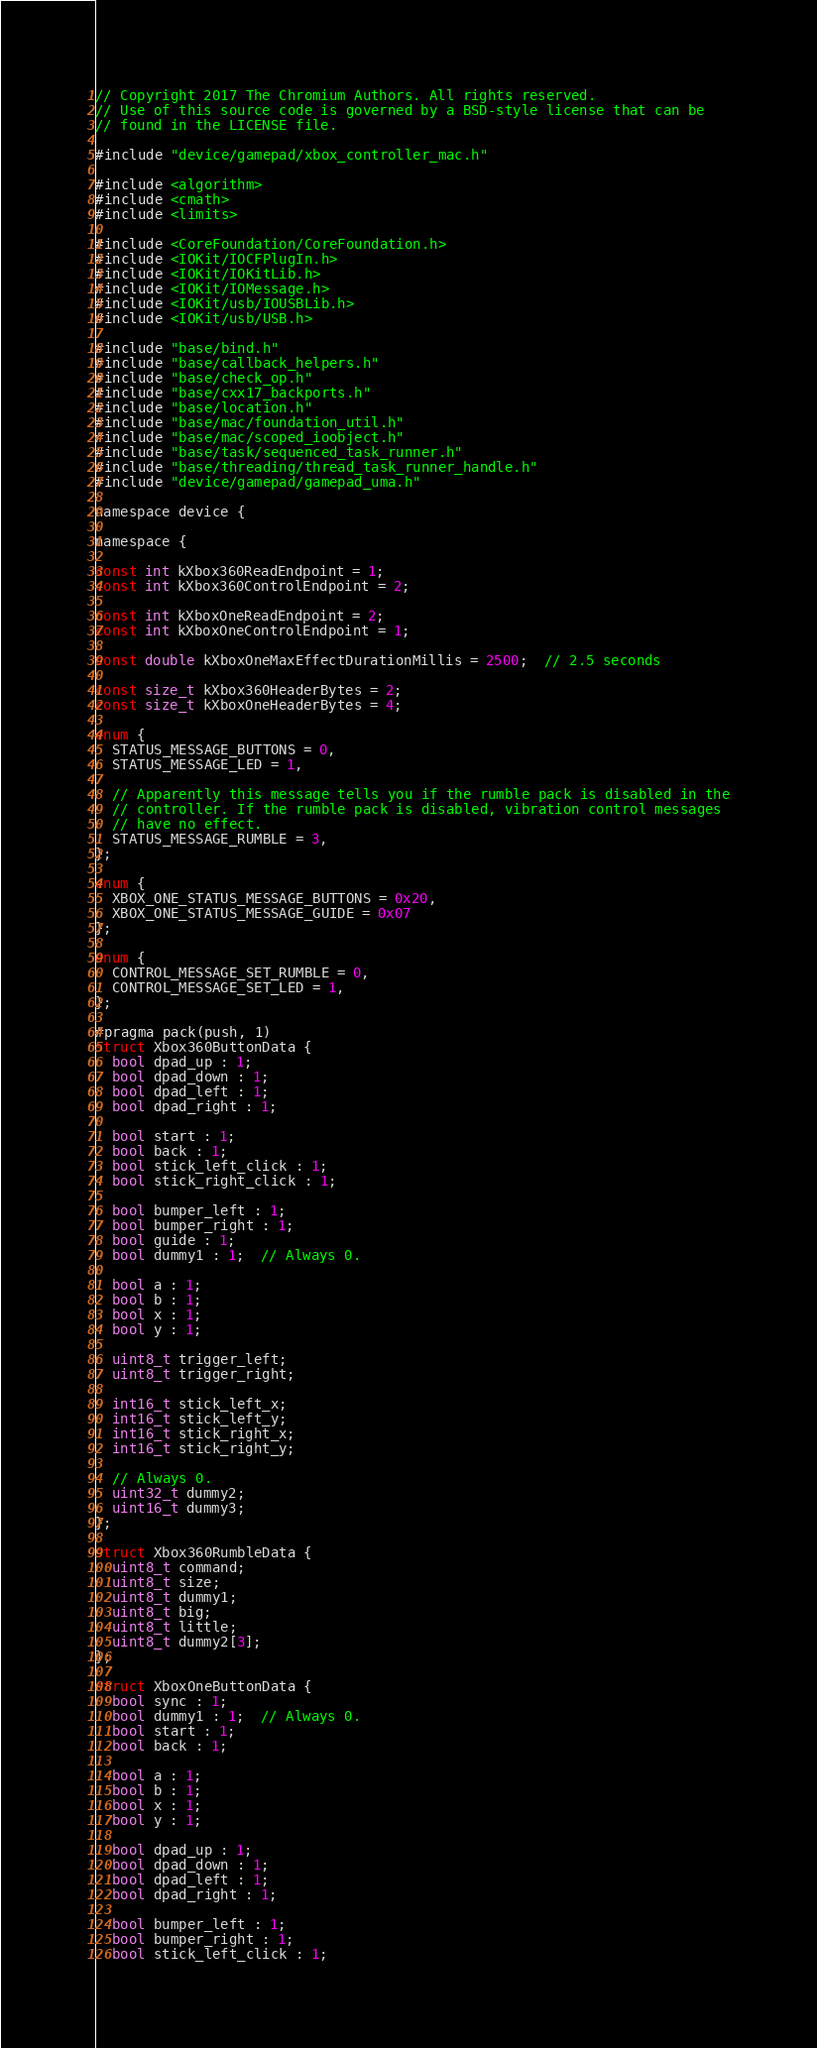<code> <loc_0><loc_0><loc_500><loc_500><_ObjectiveC_>// Copyright 2017 The Chromium Authors. All rights reserved.
// Use of this source code is governed by a BSD-style license that can be
// found in the LICENSE file.

#include "device/gamepad/xbox_controller_mac.h"

#include <algorithm>
#include <cmath>
#include <limits>

#include <CoreFoundation/CoreFoundation.h>
#include <IOKit/IOCFPlugIn.h>
#include <IOKit/IOKitLib.h>
#include <IOKit/IOMessage.h>
#include <IOKit/usb/IOUSBLib.h>
#include <IOKit/usb/USB.h>

#include "base/bind.h"
#include "base/callback_helpers.h"
#include "base/check_op.h"
#include "base/cxx17_backports.h"
#include "base/location.h"
#include "base/mac/foundation_util.h"
#include "base/mac/scoped_ioobject.h"
#include "base/task/sequenced_task_runner.h"
#include "base/threading/thread_task_runner_handle.h"
#include "device/gamepad/gamepad_uma.h"

namespace device {

namespace {

const int kXbox360ReadEndpoint = 1;
const int kXbox360ControlEndpoint = 2;

const int kXboxOneReadEndpoint = 2;
const int kXboxOneControlEndpoint = 1;

const double kXboxOneMaxEffectDurationMillis = 2500;  // 2.5 seconds

const size_t kXbox360HeaderBytes = 2;
const size_t kXboxOneHeaderBytes = 4;

enum {
  STATUS_MESSAGE_BUTTONS = 0,
  STATUS_MESSAGE_LED = 1,

  // Apparently this message tells you if the rumble pack is disabled in the
  // controller. If the rumble pack is disabled, vibration control messages
  // have no effect.
  STATUS_MESSAGE_RUMBLE = 3,
};

enum {
  XBOX_ONE_STATUS_MESSAGE_BUTTONS = 0x20,
  XBOX_ONE_STATUS_MESSAGE_GUIDE = 0x07
};

enum {
  CONTROL_MESSAGE_SET_RUMBLE = 0,
  CONTROL_MESSAGE_SET_LED = 1,
};

#pragma pack(push, 1)
struct Xbox360ButtonData {
  bool dpad_up : 1;
  bool dpad_down : 1;
  bool dpad_left : 1;
  bool dpad_right : 1;

  bool start : 1;
  bool back : 1;
  bool stick_left_click : 1;
  bool stick_right_click : 1;

  bool bumper_left : 1;
  bool bumper_right : 1;
  bool guide : 1;
  bool dummy1 : 1;  // Always 0.

  bool a : 1;
  bool b : 1;
  bool x : 1;
  bool y : 1;

  uint8_t trigger_left;
  uint8_t trigger_right;

  int16_t stick_left_x;
  int16_t stick_left_y;
  int16_t stick_right_x;
  int16_t stick_right_y;

  // Always 0.
  uint32_t dummy2;
  uint16_t dummy3;
};

struct Xbox360RumbleData {
  uint8_t command;
  uint8_t size;
  uint8_t dummy1;
  uint8_t big;
  uint8_t little;
  uint8_t dummy2[3];
};

struct XboxOneButtonData {
  bool sync : 1;
  bool dummy1 : 1;  // Always 0.
  bool start : 1;
  bool back : 1;

  bool a : 1;
  bool b : 1;
  bool x : 1;
  bool y : 1;

  bool dpad_up : 1;
  bool dpad_down : 1;
  bool dpad_left : 1;
  bool dpad_right : 1;

  bool bumper_left : 1;
  bool bumper_right : 1;
  bool stick_left_click : 1;</code> 